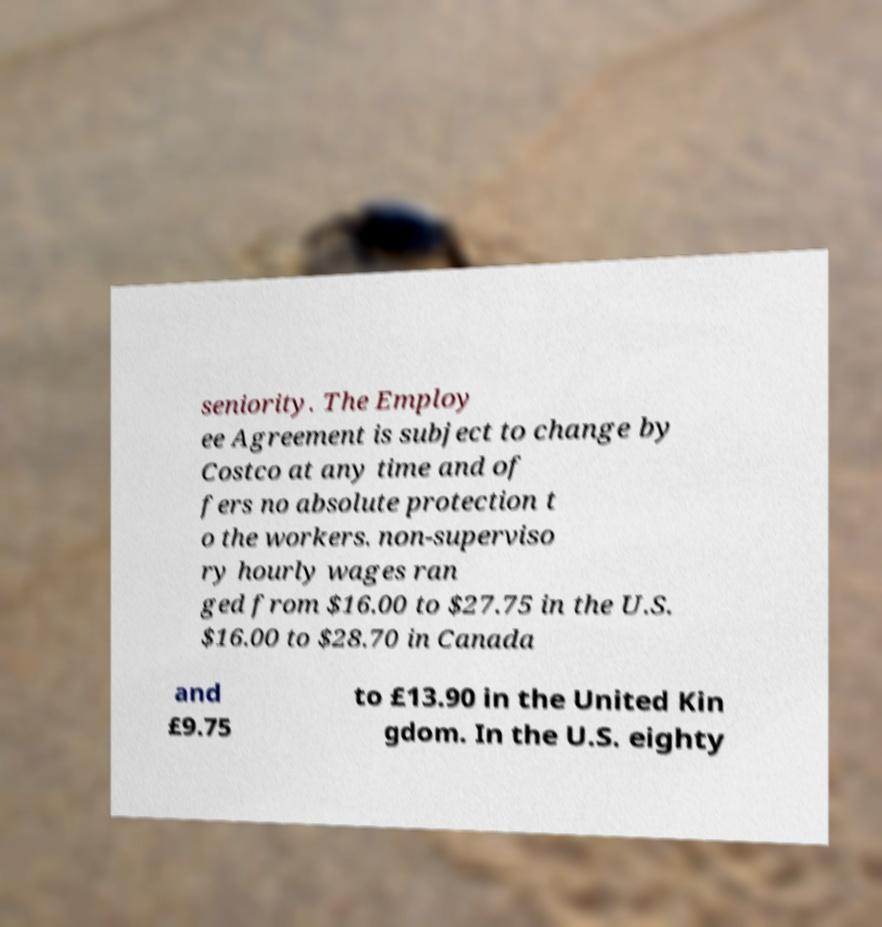There's text embedded in this image that I need extracted. Can you transcribe it verbatim? seniority. The Employ ee Agreement is subject to change by Costco at any time and of fers no absolute protection t o the workers. non-superviso ry hourly wages ran ged from $16.00 to $27.75 in the U.S. $16.00 to $28.70 in Canada and £9.75 to £13.90 in the United Kin gdom. In the U.S. eighty 